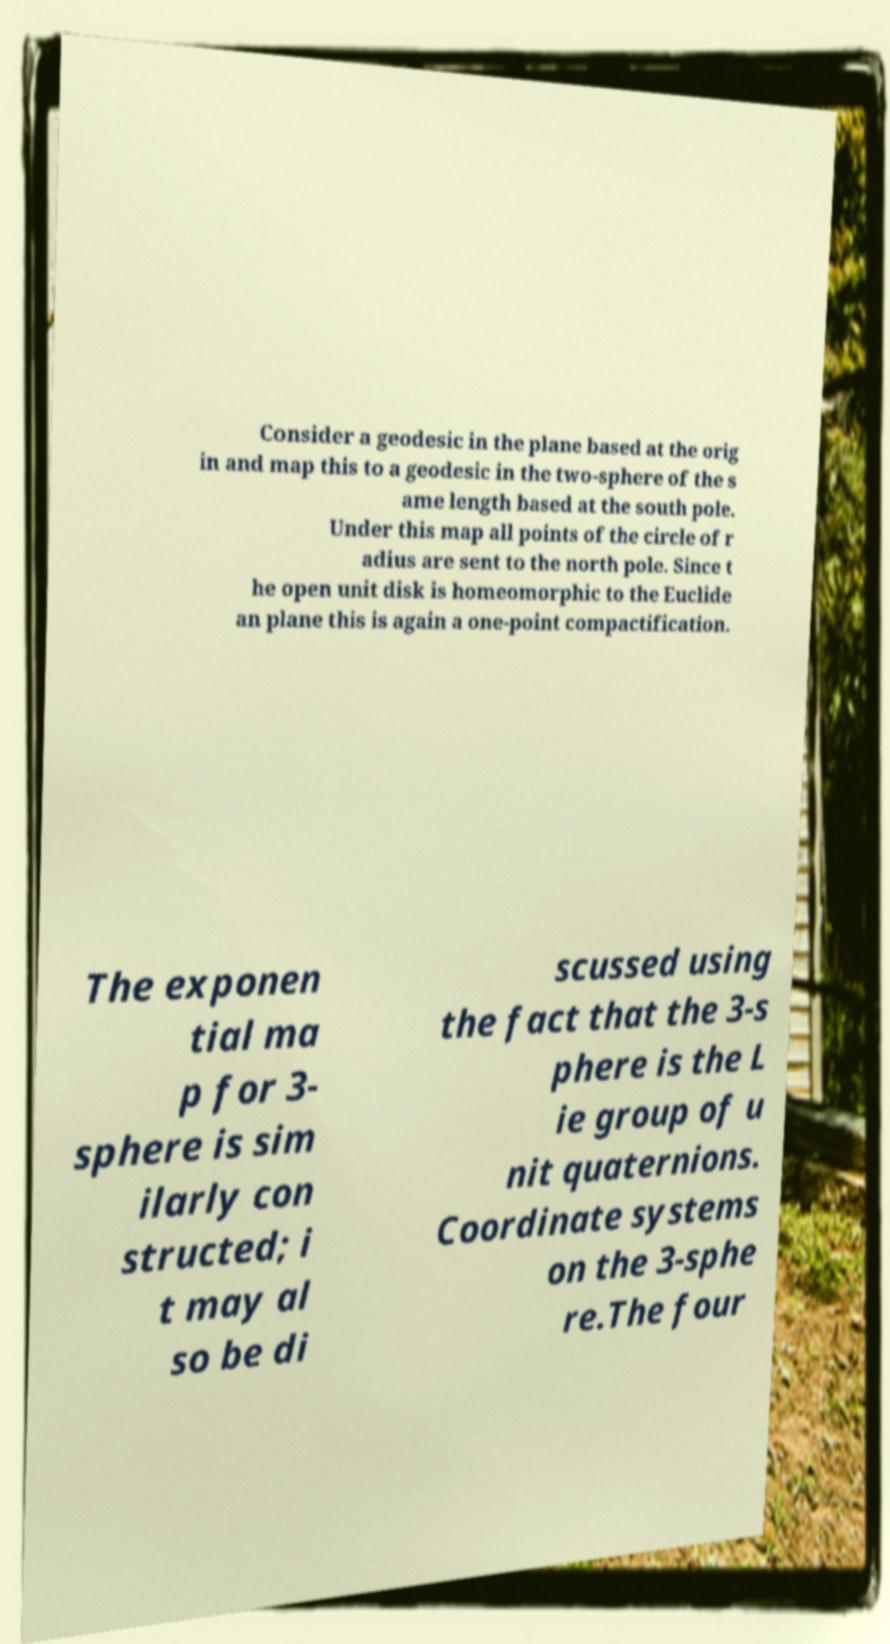Can you read and provide the text displayed in the image?This photo seems to have some interesting text. Can you extract and type it out for me? Consider a geodesic in the plane based at the orig in and map this to a geodesic in the two-sphere of the s ame length based at the south pole. Under this map all points of the circle of r adius are sent to the north pole. Since t he open unit disk is homeomorphic to the Euclide an plane this is again a one-point compactification. The exponen tial ma p for 3- sphere is sim ilarly con structed; i t may al so be di scussed using the fact that the 3-s phere is the L ie group of u nit quaternions. Coordinate systems on the 3-sphe re.The four 